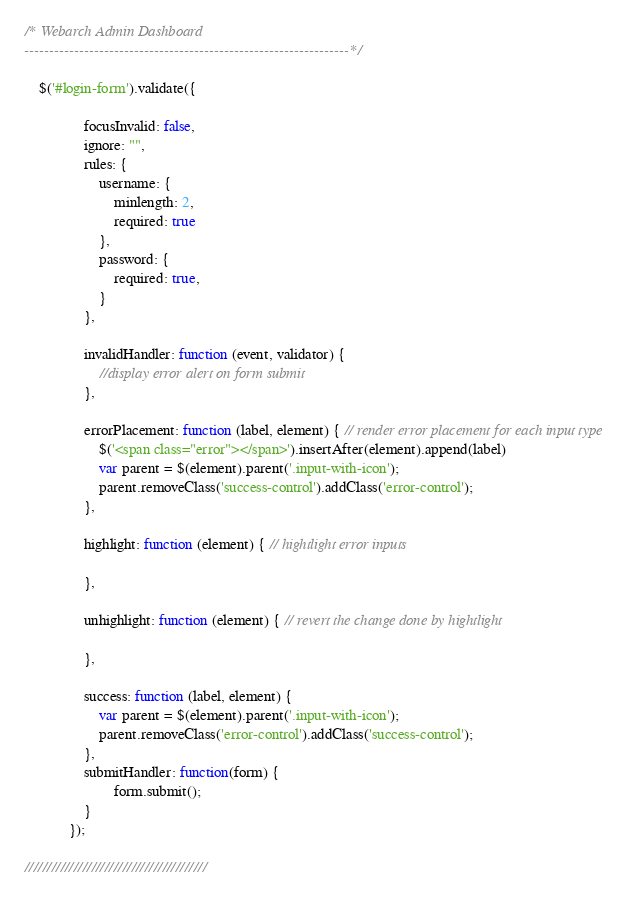<code> <loc_0><loc_0><loc_500><loc_500><_JavaScript_>/* Webarch Admin Dashboard 
-----------------------------------------------------------------*/ 
	
	$('#login-form').validate({

                focusInvalid: false, 
                ignore: "",
                rules: {
                    username: {
                        minlength: 2,
                        required: true
                    },
                    password: {
                        required: true,
                    }
                },

                invalidHandler: function (event, validator) {
					//display error alert on form submit    
                },

                errorPlacement: function (label, element) { // render error placement for each input type   
					$('<span class="error"></span>').insertAfter(element).append(label)
                    var parent = $(element).parent('.input-with-icon');
                    parent.removeClass('success-control').addClass('error-control');  
                },

                highlight: function (element) { // hightlight error inputs
					
                },

                unhighlight: function (element) { // revert the change done by hightlight
                    
                },

                success: function (label, element) {
					var parent = $(element).parent('.input-with-icon');
					parent.removeClass('error-control').addClass('success-control'); 
                },
			    submitHandler: function(form) {
						form.submit();
				}
            });	

/////////////////////////////////////////
</code> 